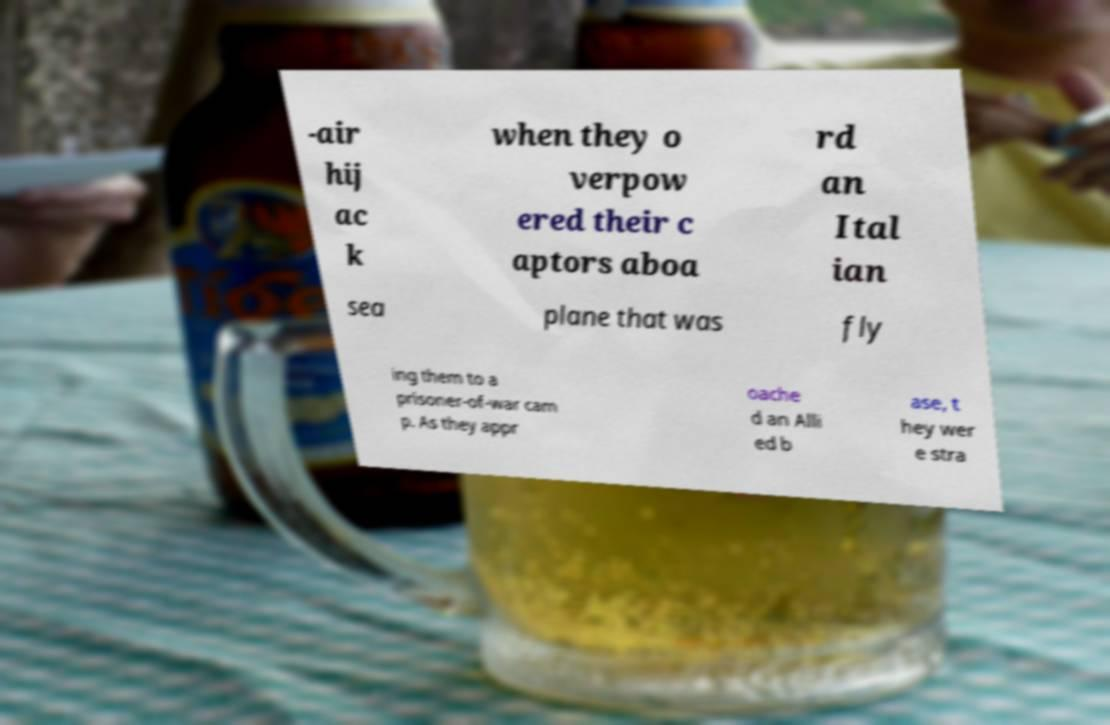Can you accurately transcribe the text from the provided image for me? -air hij ac k when they o verpow ered their c aptors aboa rd an Ital ian sea plane that was fly ing them to a prisoner-of-war cam p. As they appr oache d an Alli ed b ase, t hey wer e stra 